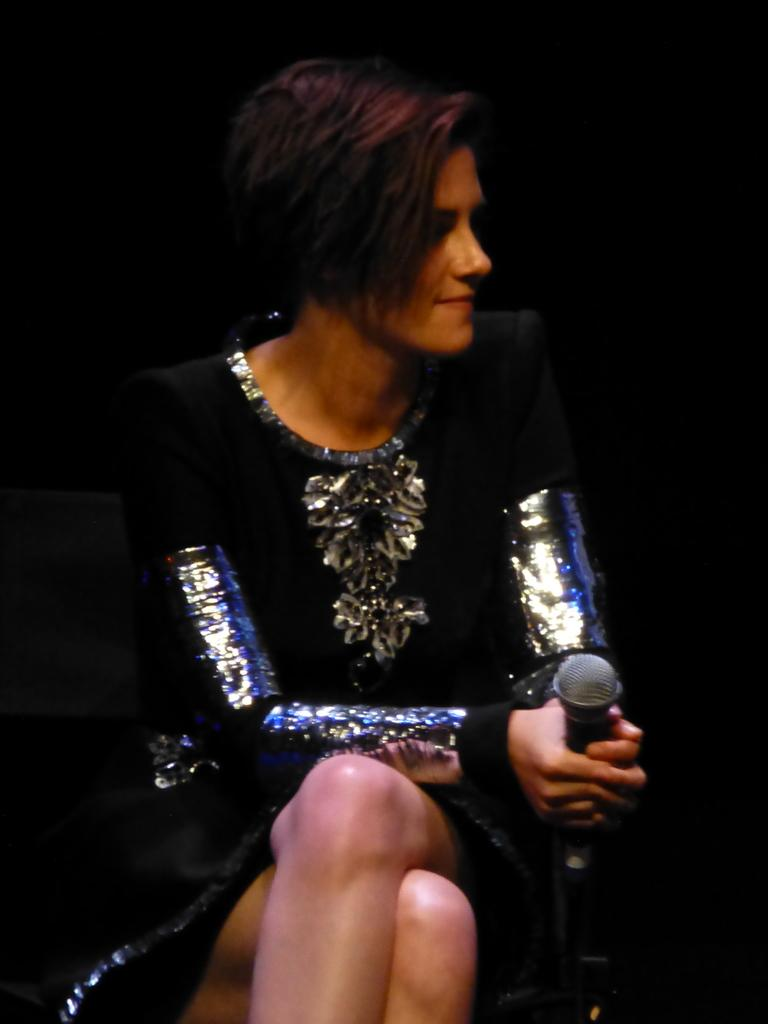Who is the main subject in the image? There is a woman in the image. What is the woman wearing? The woman is wearing a black dress. What is the woman holding in the image? The woman is holding a mic. What type of whip is the woman using in the image? There is no whip present in the image; the woman is holding a mic. What is the woman protesting about in the image? There is no protest depicted in the image; the woman is simply holding a mic. 